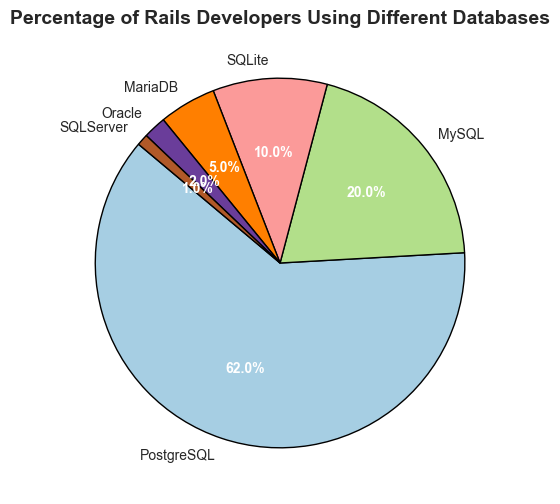What percentage of Rails developers use MySQL and MariaDB combined? According to the chart, MySQL is used by 20%, and MariaDB is used by 5%. Adding these percentages together: 20% + 5% = 25%.
Answer: 25% Which database is less popular among Rails developers, SQLite or Oracle? The chart shows that SQLite is used by 10% of developers, while Oracle is used by 2%. Since 2% is less than 10%, Oracle is less popular.
Answer: Oracle Is the percentage of Rails developers using PostgreSQL greater than the combined percentage of those using SQLite, MariaDB, and Oracle? The chart shows PostgreSQL at 62%, while SQLite, MariaDB, and Oracle are at 10%, 5%, and 2% respectively. Adding these together: 10% + 5% + 2% = 17%. Since 62% is greater than 17%, PostgreSQL's usage is indeed greater.
Answer: Yes How much more popular is SQLServer compared to Oracle among Rails developers? The chart shows that SQLServer is used by 1%, and Oracle by 2%. Since 2% - 1% = 1%, Oracle is actually more popular than SQLServer, not SQLServer more popular.
Answer: 1% less popular Identify the database with the largest slice on the pie chart. The chart indicates that PostgreSQL is represented by the largest slice, accounting for 62% of Rails developers.
Answer: PostgreSQL What is the total percentage of developers using PostgreSQL or MySQL? Adding the percentages of PostgreSQL (62%) and MySQL (20%), we get: 62% + 20% = 82%.
Answer: 82% Are there more Rails developers using SQLServer or MariaDB? The chart shows that SQLServer is used by 1% and MariaDB by 5%. Since 5% is greater than 1%, more Rails developers use MariaDB.
Answer: MariaDB Do PostgreSQL and SQLite combined account for more than half of the developer base? The chart shows PostgreSQL at 62% and SQLite at 10%. Adding these percentages together: 62% + 10% = 72%, which is more than half (50%) of the developer base.
Answer: Yes If we combine the percentages of developers using MySQL, SQLite, and MariaDB, does it surpass those using PostgreSQL alone? MySQL is at 20%, SQLite at 10%, and MariaDB at 5%. Adding these: 20% + 10% + 5% = 35%. PostgreSQL alone is at 62%. Since 35% is less than 62%, it does not surpass those using PostgreSQL alone.
Answer: No Which database has a larger slice, MySQL or SQLite? The chart shows that MySQL is used by 20% and SQLite by 10%. Since 20% is more than 10%, MySQL has the larger slice.
Answer: MySQL 